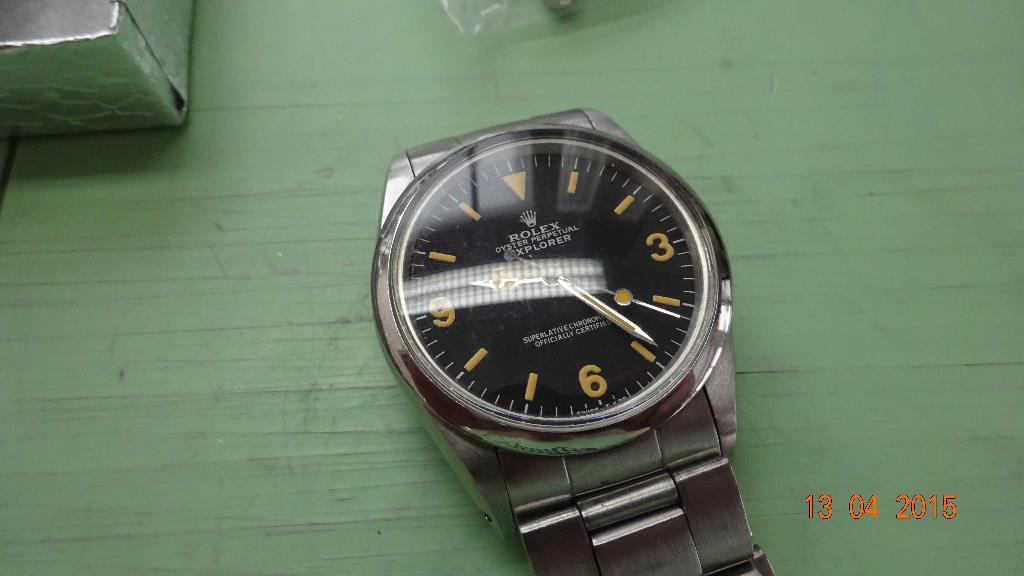<image>
Offer a succinct explanation of the picture presented. A Rolex watch has a black face and gold numbers. 